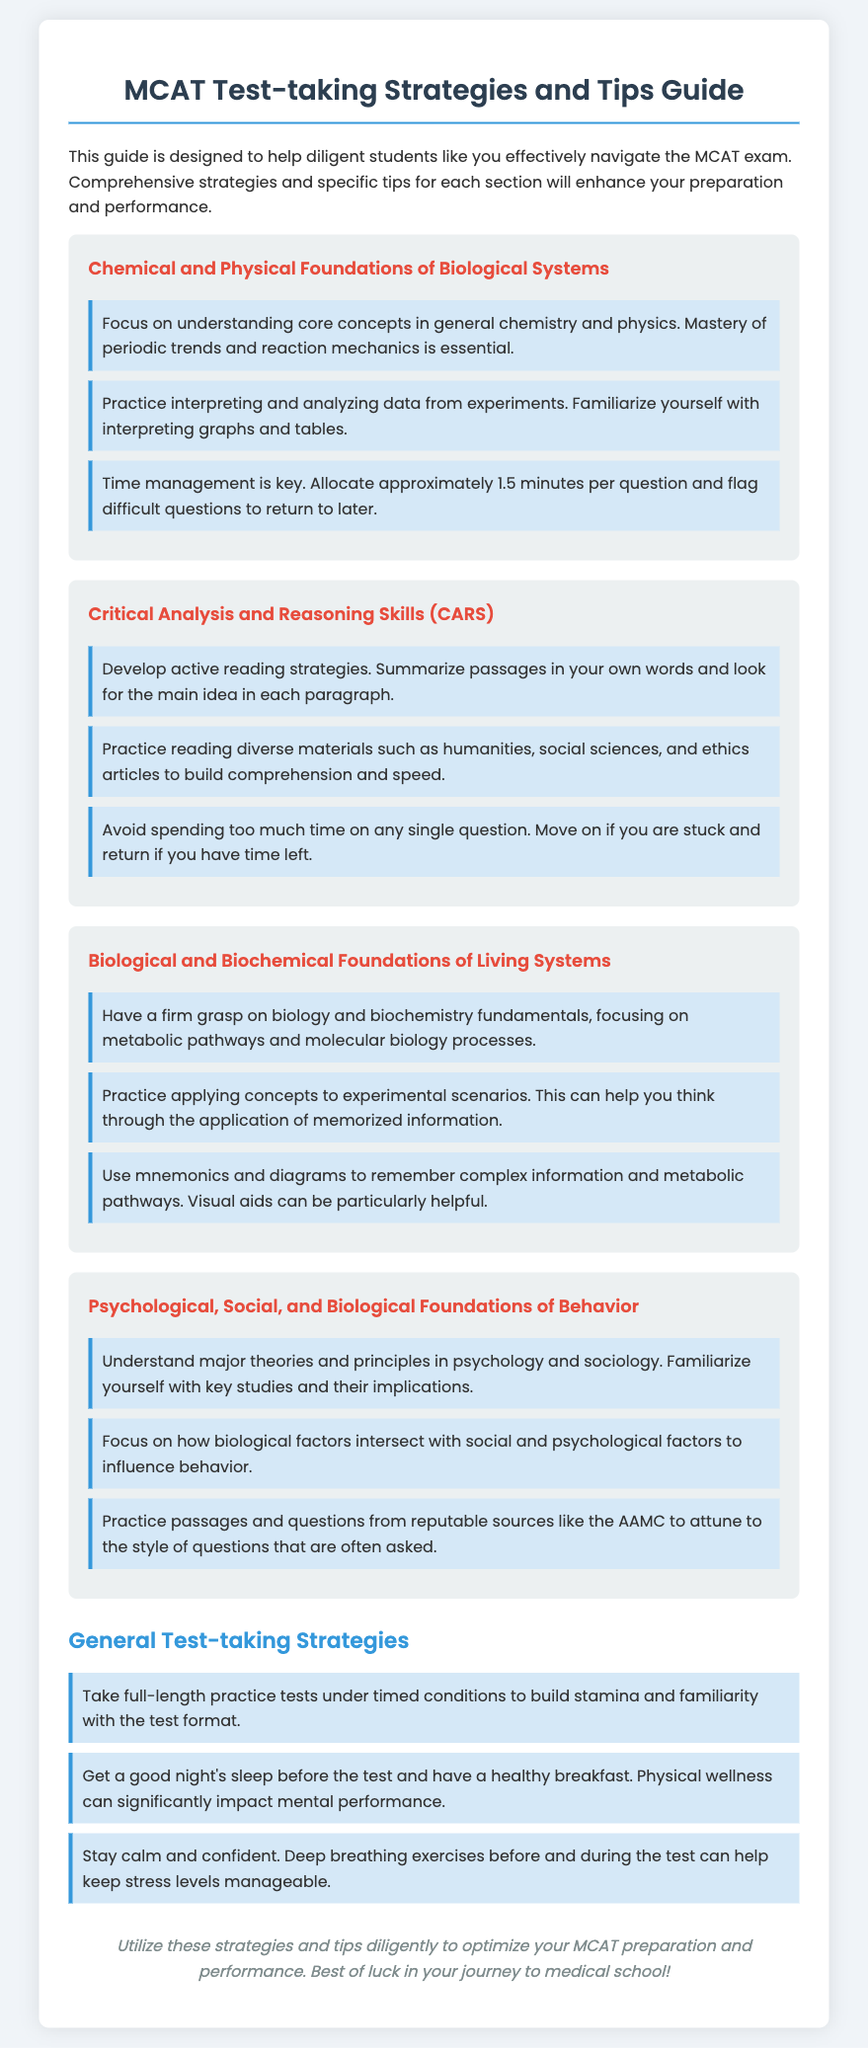What is the title of the guide? The title of the guide is stated at the top of the document.
Answer: MCAT Test-taking Strategies and Tips Guide What section focuses on psychological, social, and biological factors? This section is labeled and discussed in the document about behavior.
Answer: Psychological, Social, and Biological Foundations of Behavior How long should you allocate per question in the Chemical and Physical Foundations section? This information is specified as a time management tip for this section.
Answer: approximately 1.5 minutes What is a key strategy for the CARS section? The document provides this tip on reading strategies specific to the CARS section.
Answer: Develop active reading strategies What study focus is suggested for Biological and Biochemical Foundations? This is highlighted as a crucial area of knowledge required for this section.
Answer: metabolic pathways Name a general test-taking strategy mentioned in the guide. This information can be found in the section covering overall test-taking strategies.
Answer: Take full-length practice tests What is the recommended physical wellness action before the test? This is a tip meant to enhance mental performance on test day.
Answer: have a healthy breakfast Which strategies are emphasized for understanding psychology and sociology? The document discusses this in the context of the Psychological, Social, and Biological Foundations of Behavior section.
Answer: Understand major theories and principles 